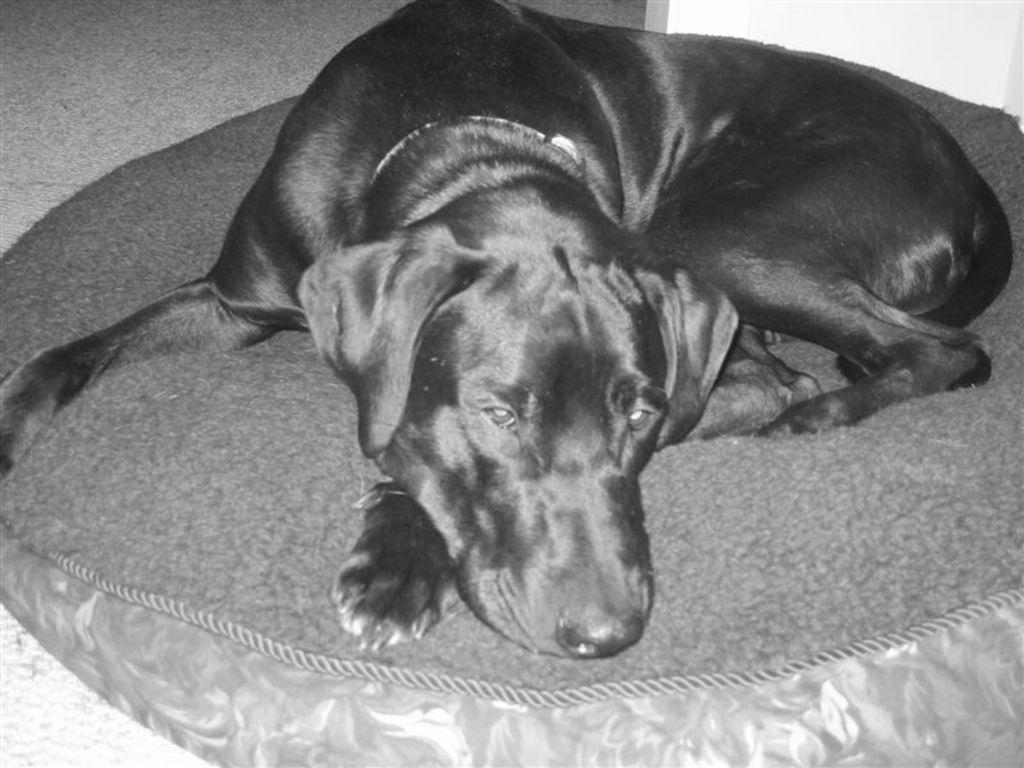What is the setting of the image? The image was likely taken indoors. What animal can be seen in the image? There is a dog in the image. What is the dog doing in the image? The dog is lying on an object. What can be seen in the background of the image? There is a wall in the background of the image. How many eggs are on the desk in the image? There is no desk or eggs present in the image. What type of pleasure can be seen being experienced by the dog in the image? There is no indication of pleasure being experienced by the dog in the image; it is simply lying on an object. 